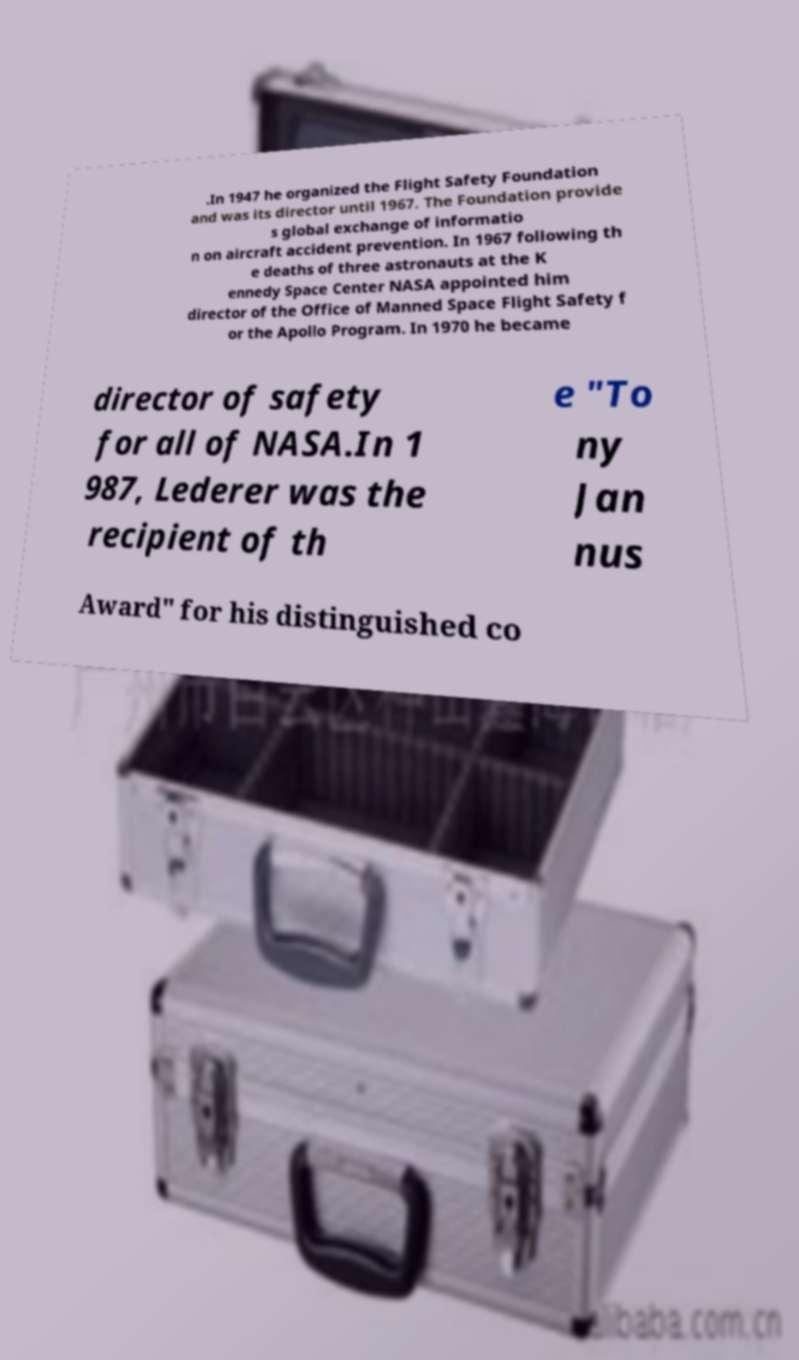What messages or text are displayed in this image? I need them in a readable, typed format. .In 1947 he organized the Flight Safety Foundation and was its director until 1967. The Foundation provide s global exchange of informatio n on aircraft accident prevention. In 1967 following th e deaths of three astronauts at the K ennedy Space Center NASA appointed him director of the Office of Manned Space Flight Safety f or the Apollo Program. In 1970 he became director of safety for all of NASA.In 1 987, Lederer was the recipient of th e "To ny Jan nus Award" for his distinguished co 